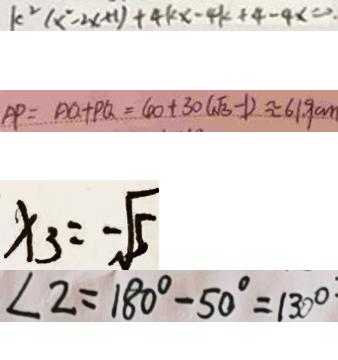Convert formula to latex. <formula><loc_0><loc_0><loc_500><loc_500>k ^ { 2 } ( x ^ { 2 } - 2 x + 1 ) + 4 k x - 4 k + 4 - 4 x = 0 . 
 A P = A Q + P Q = 4 0 + 3 0 ( \sqrt { 3 } - 1 ) \approx 6 1 . 9 c m 
 x _ { 3 } = - \sqrt { 5 } 
 \angle 2 = 1 8 0 ^ { \circ } - 5 0 ^ { \circ } = 1 3 0 ^ { \circ }</formula> 